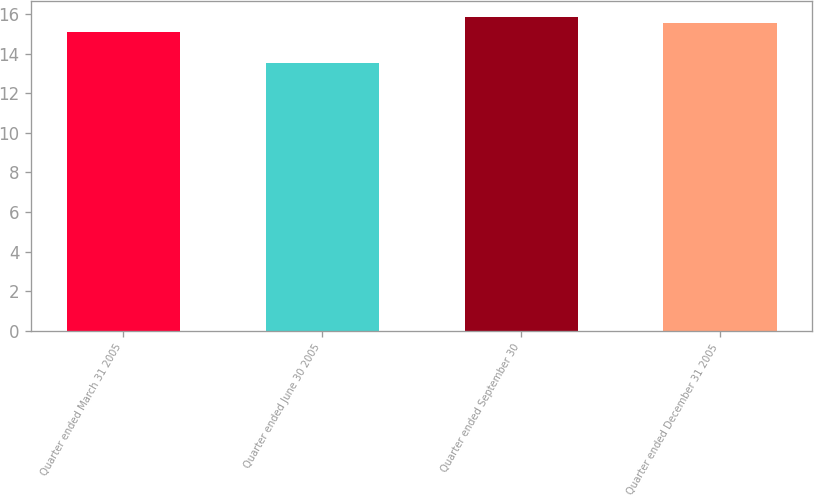Convert chart to OTSL. <chart><loc_0><loc_0><loc_500><loc_500><bar_chart><fcel>Quarter ended March 31 2005<fcel>Quarter ended June 30 2005<fcel>Quarter ended September 30<fcel>Quarter ended December 31 2005<nl><fcel>15.1<fcel>13.54<fcel>15.88<fcel>15.58<nl></chart> 